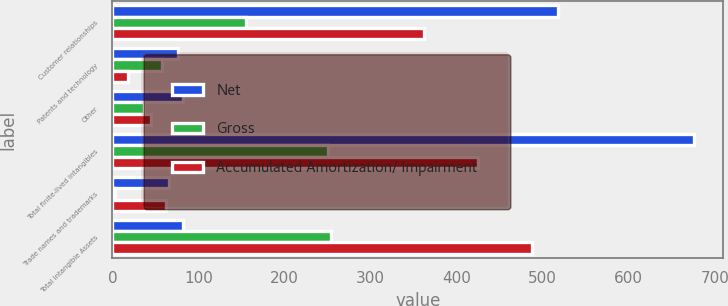Convert chart to OTSL. <chart><loc_0><loc_0><loc_500><loc_500><stacked_bar_chart><ecel><fcel>Customer relationships<fcel>Patents and technology<fcel>Other<fcel>Total finite-lived intangibles<fcel>Trade names and trademarks<fcel>Total Intangible Assets<nl><fcel>Net<fcel>517.4<fcel>76.6<fcel>81.7<fcel>675.7<fcel>66.2<fcel>81.7<nl><fcel>Gross<fcel>155.2<fcel>57.9<fcel>37.3<fcel>250.4<fcel>3.5<fcel>253.9<nl><fcel>Accumulated Amortization/ Impairment<fcel>362.2<fcel>18.7<fcel>44.4<fcel>425.3<fcel>62.7<fcel>488<nl></chart> 